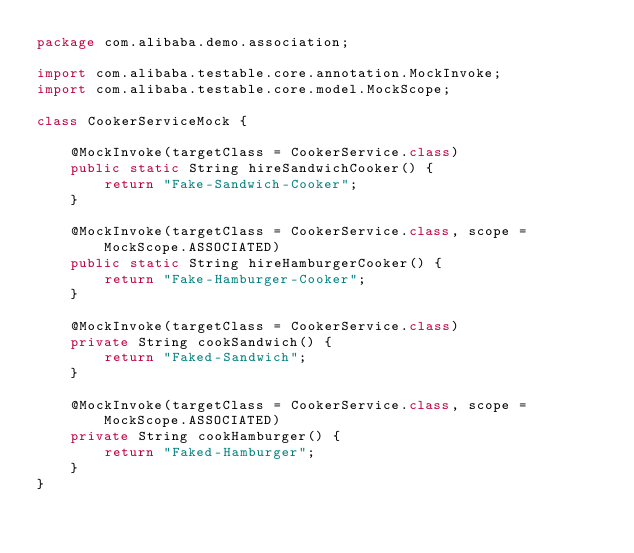Convert code to text. <code><loc_0><loc_0><loc_500><loc_500><_Java_>package com.alibaba.demo.association;

import com.alibaba.testable.core.annotation.MockInvoke;
import com.alibaba.testable.core.model.MockScope;

class CookerServiceMock {

    @MockInvoke(targetClass = CookerService.class)
    public static String hireSandwichCooker() {
        return "Fake-Sandwich-Cooker";
    }

    @MockInvoke(targetClass = CookerService.class, scope = MockScope.ASSOCIATED)
    public static String hireHamburgerCooker() {
        return "Fake-Hamburger-Cooker";
    }

    @MockInvoke(targetClass = CookerService.class)
    private String cookSandwich() {
        return "Faked-Sandwich";
    }

    @MockInvoke(targetClass = CookerService.class, scope = MockScope.ASSOCIATED)
    private String cookHamburger() {
        return "Faked-Hamburger";
    }
}
</code> 